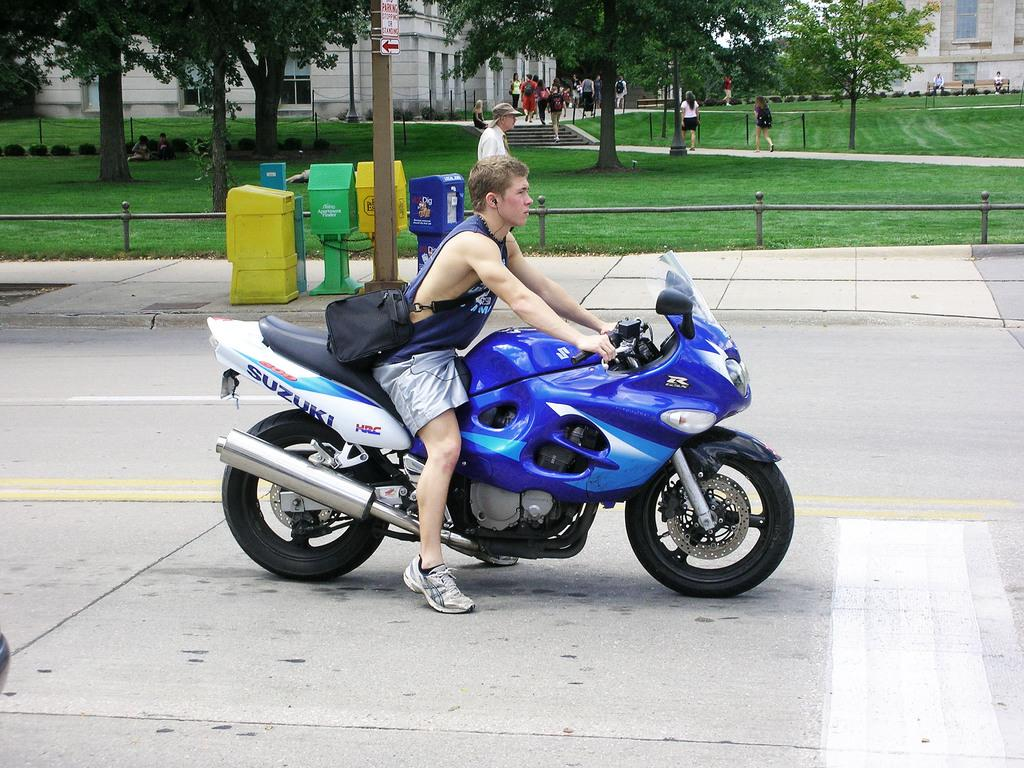What is the man in the image doing? The man is sitting on a bike in the image. What is the man holding while sitting on the bike? The man is holding a bag across his shoulders. Where is the bike located in the image? The bike is on the road in the image. What can be seen in the background of the image? There are post boxes, a pole, trees, and buildings in the background of the image. How many mice are sitting on the man's shoulders in the image? There are no mice present in the image; the man is holding a bag across his shoulders. 